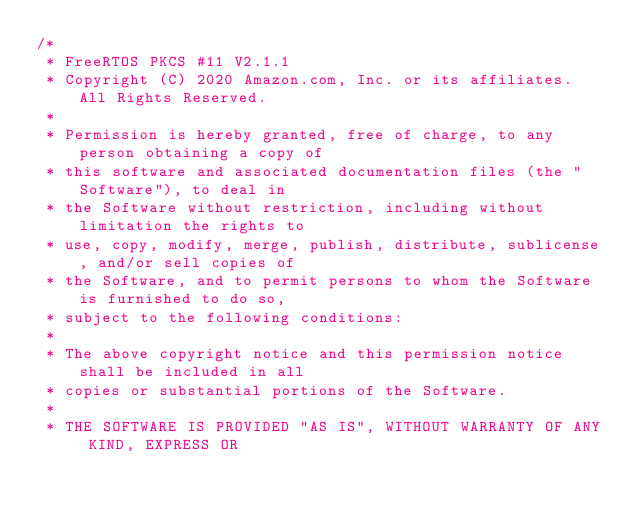<code> <loc_0><loc_0><loc_500><loc_500><_C_>/*
 * FreeRTOS PKCS #11 V2.1.1
 * Copyright (C) 2020 Amazon.com, Inc. or its affiliates.  All Rights Reserved.
 *
 * Permission is hereby granted, free of charge, to any person obtaining a copy of
 * this software and associated documentation files (the "Software"), to deal in
 * the Software without restriction, including without limitation the rights to
 * use, copy, modify, merge, publish, distribute, sublicense, and/or sell copies of
 * the Software, and to permit persons to whom the Software is furnished to do so,
 * subject to the following conditions:
 *
 * The above copyright notice and this permission notice shall be included in all
 * copies or substantial portions of the Software.
 *
 * THE SOFTWARE IS PROVIDED "AS IS", WITHOUT WARRANTY OF ANY KIND, EXPRESS OR</code> 